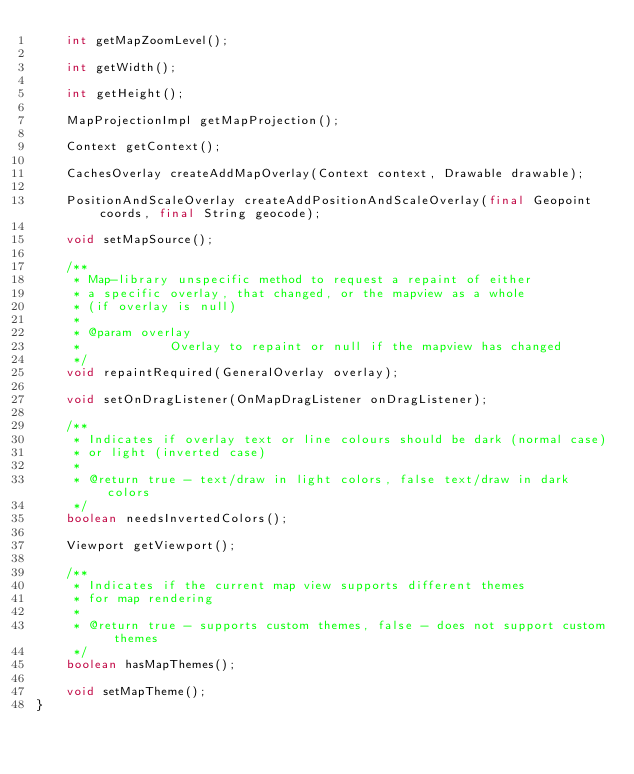<code> <loc_0><loc_0><loc_500><loc_500><_Java_>    int getMapZoomLevel();

    int getWidth();

    int getHeight();

    MapProjectionImpl getMapProjection();

    Context getContext();

    CachesOverlay createAddMapOverlay(Context context, Drawable drawable);

    PositionAndScaleOverlay createAddPositionAndScaleOverlay(final Geopoint coords, final String geocode);

    void setMapSource();

    /**
     * Map-library unspecific method to request a repaint of either
     * a specific overlay, that changed, or the mapview as a whole
     * (if overlay is null)
     *
     * @param overlay
     *            Overlay to repaint or null if the mapview has changed
     */
    void repaintRequired(GeneralOverlay overlay);

    void setOnDragListener(OnMapDragListener onDragListener);

    /**
     * Indicates if overlay text or line colours should be dark (normal case)
     * or light (inverted case)
     *
     * @return true - text/draw in light colors, false text/draw in dark colors
     */
    boolean needsInvertedColors();

    Viewport getViewport();

    /**
     * Indicates if the current map view supports different themes
     * for map rendering
     *
     * @return true - supports custom themes, false - does not support custom themes
     */
    boolean hasMapThemes();

    void setMapTheme();
}
</code> 